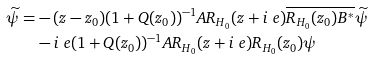<formula> <loc_0><loc_0><loc_500><loc_500>\widetilde { \psi } = & - ( z - z _ { 0 } ) ( 1 + Q ( z _ { 0 } ) ) ^ { - 1 } A R _ { H _ { 0 } } ( z + i \ e ) \overline { R _ { H _ { 0 } } ( z _ { 0 } ) B ^ { * } } \widetilde { \psi } \\ & - i \ e ( 1 + Q ( z _ { 0 } ) ) ^ { - 1 } A R _ { H _ { 0 } } ( z + i \ e ) R _ { H _ { 0 } } ( z _ { 0 } ) \psi</formula> 